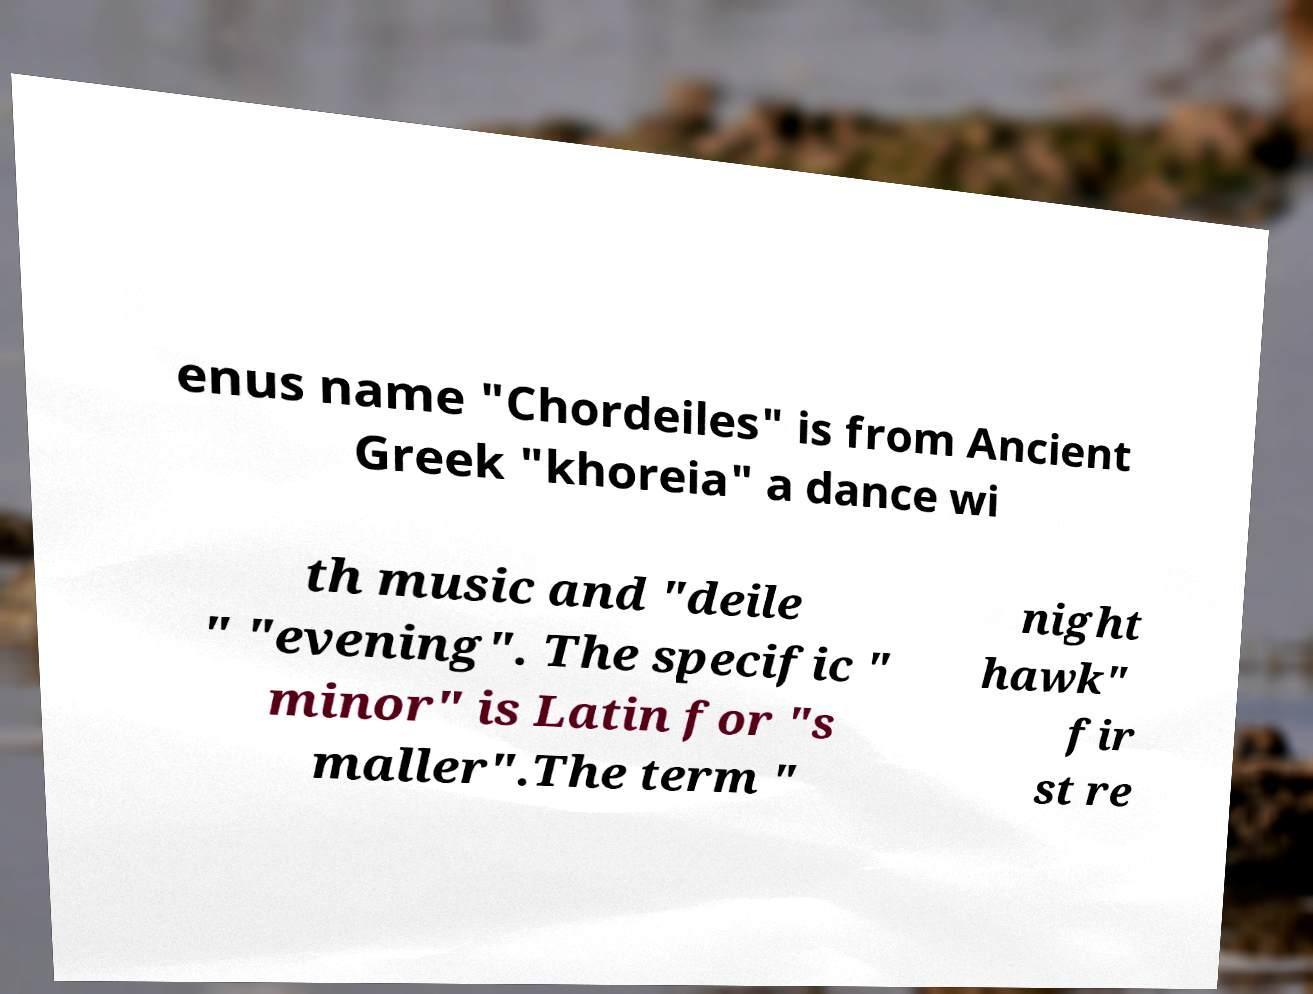I need the written content from this picture converted into text. Can you do that? enus name "Chordeiles" is from Ancient Greek "khoreia" a dance wi th music and "deile " "evening". The specific " minor" is Latin for "s maller".The term " night hawk" fir st re 